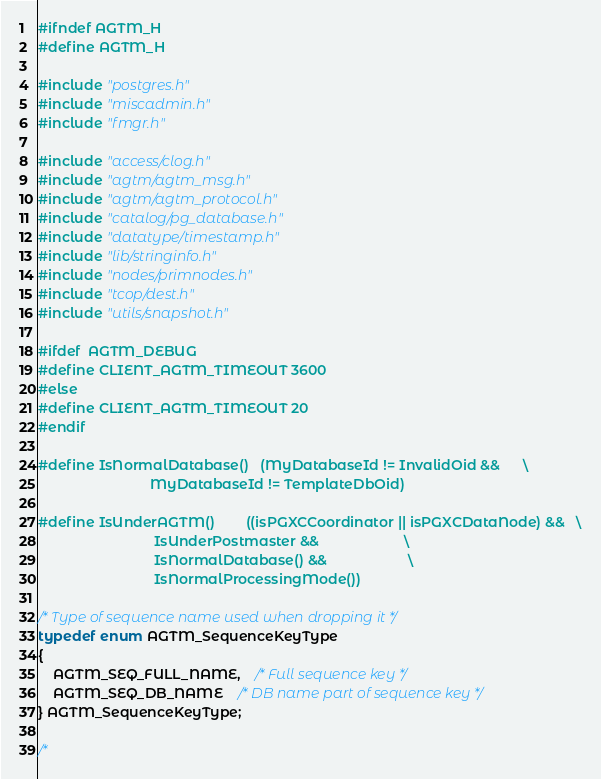<code> <loc_0><loc_0><loc_500><loc_500><_C_>#ifndef AGTM_H
#define AGTM_H

#include "postgres.h"
#include "miscadmin.h"
#include "fmgr.h"

#include "access/clog.h"
#include "agtm/agtm_msg.h"
#include "agtm/agtm_protocol.h"
#include "catalog/pg_database.h"
#include "datatype/timestamp.h"
#include "lib/stringinfo.h"
#include "nodes/primnodes.h"
#include "tcop/dest.h"
#include "utils/snapshot.h"

#ifdef  AGTM_DEBUG
#define CLIENT_AGTM_TIMEOUT 3600
#else
#define CLIENT_AGTM_TIMEOUT 20
#endif

#define IsNormalDatabase()	(MyDatabaseId != InvalidOid &&		\
							 MyDatabaseId != TemplateDbOid)

#define IsUnderAGTM()		((isPGXCCoordinator || isPGXCDataNode) &&	\
							  IsUnderPostmaster &&						\
							  IsNormalDatabase() &&						\
							  IsNormalProcessingMode())

/* Type of sequence name used when dropping it */
typedef enum AGTM_SequenceKeyType
{
	AGTM_SEQ_FULL_NAME,	/* Full sequence key */
	AGTM_SEQ_DB_NAME 	/* DB name part of sequence key */
} AGTM_SequenceKeyType;

/*</code> 